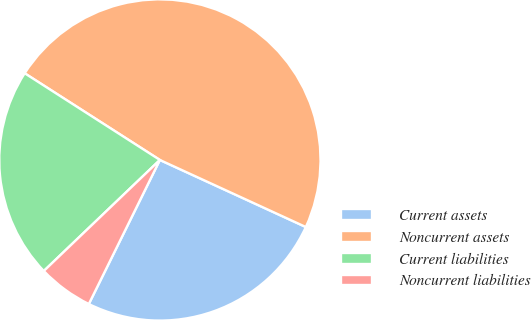<chart> <loc_0><loc_0><loc_500><loc_500><pie_chart><fcel>Current assets<fcel>Noncurrent assets<fcel>Current liabilities<fcel>Noncurrent liabilities<nl><fcel>25.44%<fcel>47.78%<fcel>21.22%<fcel>5.56%<nl></chart> 